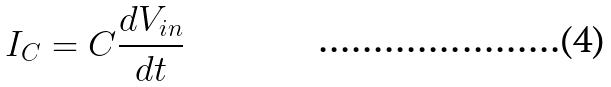<formula> <loc_0><loc_0><loc_500><loc_500>I _ { C } = C \frac { d V _ { i n } } { d t }</formula> 